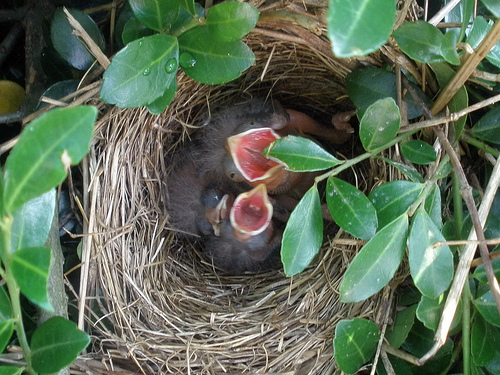How many birds are there? There are three baby birds in the nest, eagerly waiting with their mouths wide open, probably anticipating a feeding from their parent soon. 